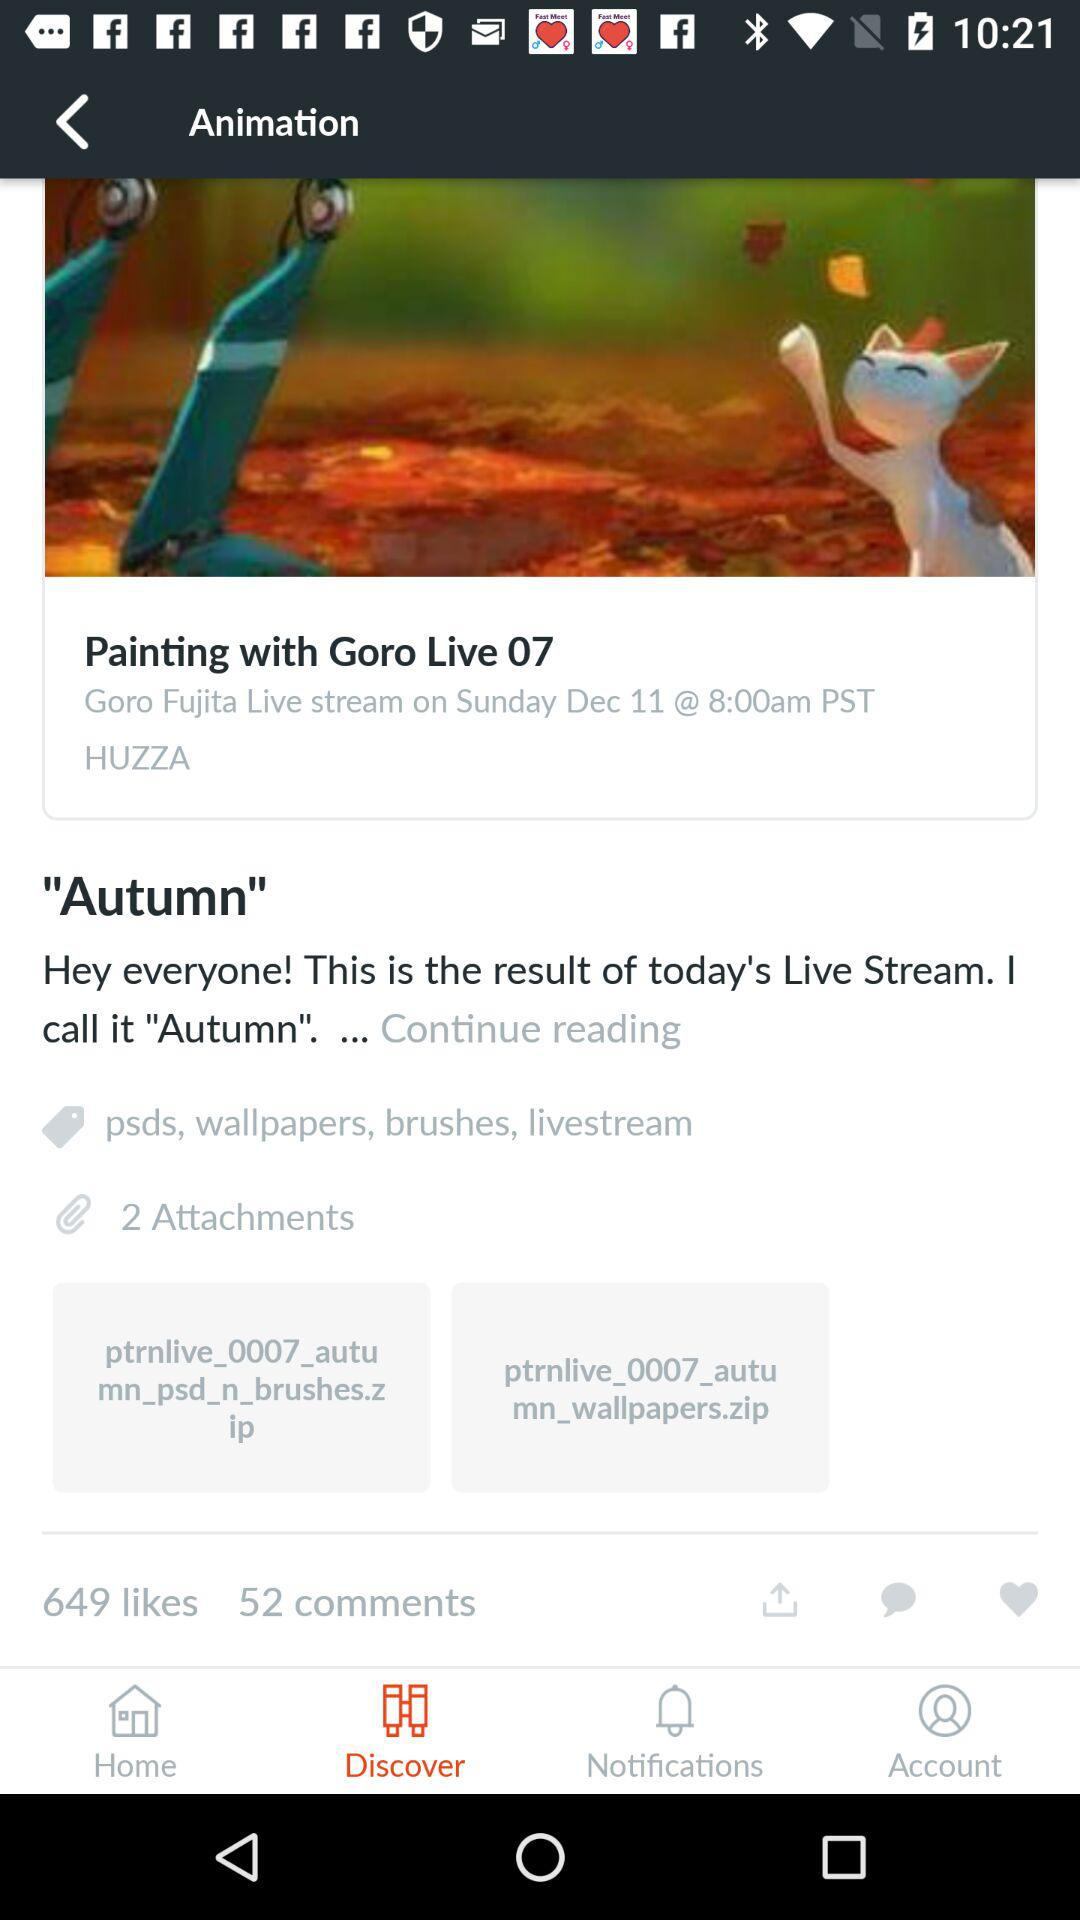How many attachments are there?
Answer the question using a single word or phrase. 2 